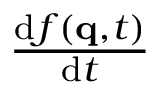Convert formula to latex. <formula><loc_0><loc_0><loc_500><loc_500>\frac { d f ( q , t ) } { d t }</formula> 